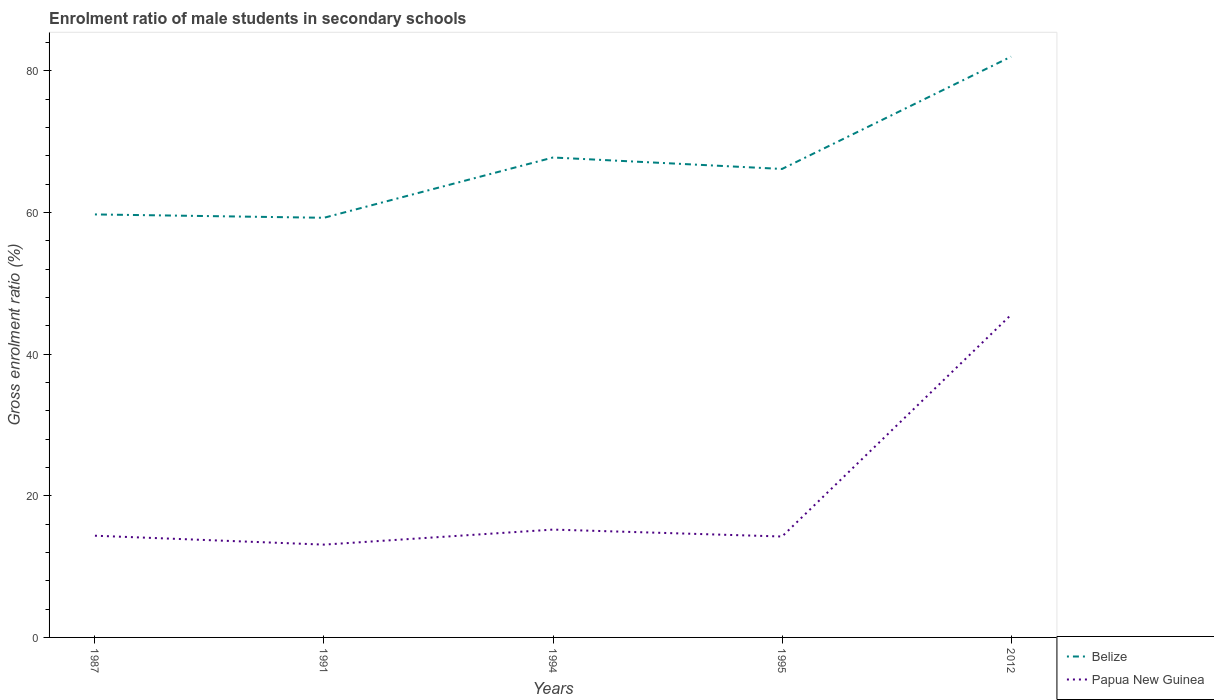Does the line corresponding to Papua New Guinea intersect with the line corresponding to Belize?
Your response must be concise. No. Is the number of lines equal to the number of legend labels?
Make the answer very short. Yes. Across all years, what is the maximum enrolment ratio of male students in secondary schools in Belize?
Give a very brief answer. 59.25. What is the total enrolment ratio of male students in secondary schools in Belize in the graph?
Offer a very short reply. -14.24. What is the difference between the highest and the second highest enrolment ratio of male students in secondary schools in Belize?
Make the answer very short. 22.75. Is the enrolment ratio of male students in secondary schools in Belize strictly greater than the enrolment ratio of male students in secondary schools in Papua New Guinea over the years?
Give a very brief answer. No. How many years are there in the graph?
Offer a terse response. 5. What is the difference between two consecutive major ticks on the Y-axis?
Offer a very short reply. 20. Are the values on the major ticks of Y-axis written in scientific E-notation?
Make the answer very short. No. What is the title of the graph?
Offer a terse response. Enrolment ratio of male students in secondary schools. Does "Jordan" appear as one of the legend labels in the graph?
Offer a terse response. No. What is the label or title of the X-axis?
Provide a succinct answer. Years. What is the Gross enrolment ratio (%) of Belize in 1987?
Make the answer very short. 59.72. What is the Gross enrolment ratio (%) of Papua New Guinea in 1987?
Your response must be concise. 14.36. What is the Gross enrolment ratio (%) of Belize in 1991?
Your answer should be compact. 59.25. What is the Gross enrolment ratio (%) in Papua New Guinea in 1991?
Offer a terse response. 13.1. What is the Gross enrolment ratio (%) in Belize in 1994?
Ensure brevity in your answer.  67.76. What is the Gross enrolment ratio (%) of Papua New Guinea in 1994?
Offer a terse response. 15.23. What is the Gross enrolment ratio (%) in Belize in 1995?
Your response must be concise. 66.14. What is the Gross enrolment ratio (%) of Papua New Guinea in 1995?
Keep it short and to the point. 14.25. What is the Gross enrolment ratio (%) in Belize in 2012?
Your response must be concise. 81.99. What is the Gross enrolment ratio (%) in Papua New Guinea in 2012?
Give a very brief answer. 45.56. Across all years, what is the maximum Gross enrolment ratio (%) in Belize?
Your answer should be very brief. 81.99. Across all years, what is the maximum Gross enrolment ratio (%) in Papua New Guinea?
Your answer should be very brief. 45.56. Across all years, what is the minimum Gross enrolment ratio (%) of Belize?
Your answer should be very brief. 59.25. Across all years, what is the minimum Gross enrolment ratio (%) of Papua New Guinea?
Give a very brief answer. 13.1. What is the total Gross enrolment ratio (%) in Belize in the graph?
Provide a short and direct response. 334.85. What is the total Gross enrolment ratio (%) in Papua New Guinea in the graph?
Provide a succinct answer. 102.49. What is the difference between the Gross enrolment ratio (%) of Belize in 1987 and that in 1991?
Keep it short and to the point. 0.47. What is the difference between the Gross enrolment ratio (%) in Papua New Guinea in 1987 and that in 1991?
Keep it short and to the point. 1.26. What is the difference between the Gross enrolment ratio (%) of Belize in 1987 and that in 1994?
Give a very brief answer. -8.04. What is the difference between the Gross enrolment ratio (%) in Papua New Guinea in 1987 and that in 1994?
Make the answer very short. -0.87. What is the difference between the Gross enrolment ratio (%) of Belize in 1987 and that in 1995?
Provide a succinct answer. -6.42. What is the difference between the Gross enrolment ratio (%) of Papua New Guinea in 1987 and that in 1995?
Give a very brief answer. 0.11. What is the difference between the Gross enrolment ratio (%) in Belize in 1987 and that in 2012?
Offer a terse response. -22.27. What is the difference between the Gross enrolment ratio (%) of Papua New Guinea in 1987 and that in 2012?
Your answer should be very brief. -31.2. What is the difference between the Gross enrolment ratio (%) in Belize in 1991 and that in 1994?
Your response must be concise. -8.51. What is the difference between the Gross enrolment ratio (%) in Papua New Guinea in 1991 and that in 1994?
Your answer should be compact. -2.12. What is the difference between the Gross enrolment ratio (%) in Belize in 1991 and that in 1995?
Provide a succinct answer. -6.89. What is the difference between the Gross enrolment ratio (%) of Papua New Guinea in 1991 and that in 1995?
Your response must be concise. -1.14. What is the difference between the Gross enrolment ratio (%) in Belize in 1991 and that in 2012?
Ensure brevity in your answer.  -22.75. What is the difference between the Gross enrolment ratio (%) in Papua New Guinea in 1991 and that in 2012?
Your answer should be very brief. -32.45. What is the difference between the Gross enrolment ratio (%) of Belize in 1994 and that in 1995?
Your answer should be compact. 1.62. What is the difference between the Gross enrolment ratio (%) in Papua New Guinea in 1994 and that in 1995?
Keep it short and to the point. 0.98. What is the difference between the Gross enrolment ratio (%) of Belize in 1994 and that in 2012?
Give a very brief answer. -14.24. What is the difference between the Gross enrolment ratio (%) of Papua New Guinea in 1994 and that in 2012?
Make the answer very short. -30.33. What is the difference between the Gross enrolment ratio (%) of Belize in 1995 and that in 2012?
Your answer should be very brief. -15.86. What is the difference between the Gross enrolment ratio (%) in Papua New Guinea in 1995 and that in 2012?
Ensure brevity in your answer.  -31.31. What is the difference between the Gross enrolment ratio (%) of Belize in 1987 and the Gross enrolment ratio (%) of Papua New Guinea in 1991?
Provide a short and direct response. 46.62. What is the difference between the Gross enrolment ratio (%) of Belize in 1987 and the Gross enrolment ratio (%) of Papua New Guinea in 1994?
Give a very brief answer. 44.49. What is the difference between the Gross enrolment ratio (%) of Belize in 1987 and the Gross enrolment ratio (%) of Papua New Guinea in 1995?
Ensure brevity in your answer.  45.47. What is the difference between the Gross enrolment ratio (%) of Belize in 1987 and the Gross enrolment ratio (%) of Papua New Guinea in 2012?
Your answer should be very brief. 14.16. What is the difference between the Gross enrolment ratio (%) in Belize in 1991 and the Gross enrolment ratio (%) in Papua New Guinea in 1994?
Provide a succinct answer. 44.02. What is the difference between the Gross enrolment ratio (%) in Belize in 1991 and the Gross enrolment ratio (%) in Papua New Guinea in 1995?
Offer a very short reply. 45. What is the difference between the Gross enrolment ratio (%) in Belize in 1991 and the Gross enrolment ratio (%) in Papua New Guinea in 2012?
Offer a very short reply. 13.69. What is the difference between the Gross enrolment ratio (%) of Belize in 1994 and the Gross enrolment ratio (%) of Papua New Guinea in 1995?
Ensure brevity in your answer.  53.51. What is the difference between the Gross enrolment ratio (%) of Belize in 1994 and the Gross enrolment ratio (%) of Papua New Guinea in 2012?
Your answer should be very brief. 22.2. What is the difference between the Gross enrolment ratio (%) in Belize in 1995 and the Gross enrolment ratio (%) in Papua New Guinea in 2012?
Make the answer very short. 20.58. What is the average Gross enrolment ratio (%) in Belize per year?
Make the answer very short. 66.97. What is the average Gross enrolment ratio (%) of Papua New Guinea per year?
Provide a short and direct response. 20.5. In the year 1987, what is the difference between the Gross enrolment ratio (%) of Belize and Gross enrolment ratio (%) of Papua New Guinea?
Offer a terse response. 45.36. In the year 1991, what is the difference between the Gross enrolment ratio (%) in Belize and Gross enrolment ratio (%) in Papua New Guinea?
Provide a short and direct response. 46.14. In the year 1994, what is the difference between the Gross enrolment ratio (%) in Belize and Gross enrolment ratio (%) in Papua New Guinea?
Make the answer very short. 52.53. In the year 1995, what is the difference between the Gross enrolment ratio (%) in Belize and Gross enrolment ratio (%) in Papua New Guinea?
Offer a terse response. 51.89. In the year 2012, what is the difference between the Gross enrolment ratio (%) of Belize and Gross enrolment ratio (%) of Papua New Guinea?
Give a very brief answer. 36.44. What is the ratio of the Gross enrolment ratio (%) of Belize in 1987 to that in 1991?
Offer a terse response. 1.01. What is the ratio of the Gross enrolment ratio (%) in Papua New Guinea in 1987 to that in 1991?
Provide a succinct answer. 1.1. What is the ratio of the Gross enrolment ratio (%) of Belize in 1987 to that in 1994?
Provide a succinct answer. 0.88. What is the ratio of the Gross enrolment ratio (%) of Papua New Guinea in 1987 to that in 1994?
Provide a succinct answer. 0.94. What is the ratio of the Gross enrolment ratio (%) in Belize in 1987 to that in 1995?
Offer a terse response. 0.9. What is the ratio of the Gross enrolment ratio (%) of Belize in 1987 to that in 2012?
Provide a short and direct response. 0.73. What is the ratio of the Gross enrolment ratio (%) in Papua New Guinea in 1987 to that in 2012?
Provide a short and direct response. 0.32. What is the ratio of the Gross enrolment ratio (%) of Belize in 1991 to that in 1994?
Provide a succinct answer. 0.87. What is the ratio of the Gross enrolment ratio (%) in Papua New Guinea in 1991 to that in 1994?
Provide a short and direct response. 0.86. What is the ratio of the Gross enrolment ratio (%) in Belize in 1991 to that in 1995?
Ensure brevity in your answer.  0.9. What is the ratio of the Gross enrolment ratio (%) in Papua New Guinea in 1991 to that in 1995?
Ensure brevity in your answer.  0.92. What is the ratio of the Gross enrolment ratio (%) of Belize in 1991 to that in 2012?
Provide a short and direct response. 0.72. What is the ratio of the Gross enrolment ratio (%) in Papua New Guinea in 1991 to that in 2012?
Offer a terse response. 0.29. What is the ratio of the Gross enrolment ratio (%) in Belize in 1994 to that in 1995?
Provide a short and direct response. 1.02. What is the ratio of the Gross enrolment ratio (%) in Papua New Guinea in 1994 to that in 1995?
Your answer should be compact. 1.07. What is the ratio of the Gross enrolment ratio (%) in Belize in 1994 to that in 2012?
Keep it short and to the point. 0.83. What is the ratio of the Gross enrolment ratio (%) in Papua New Guinea in 1994 to that in 2012?
Give a very brief answer. 0.33. What is the ratio of the Gross enrolment ratio (%) of Belize in 1995 to that in 2012?
Ensure brevity in your answer.  0.81. What is the ratio of the Gross enrolment ratio (%) of Papua New Guinea in 1995 to that in 2012?
Offer a terse response. 0.31. What is the difference between the highest and the second highest Gross enrolment ratio (%) in Belize?
Your answer should be very brief. 14.24. What is the difference between the highest and the second highest Gross enrolment ratio (%) in Papua New Guinea?
Your answer should be compact. 30.33. What is the difference between the highest and the lowest Gross enrolment ratio (%) of Belize?
Your answer should be very brief. 22.75. What is the difference between the highest and the lowest Gross enrolment ratio (%) in Papua New Guinea?
Provide a succinct answer. 32.45. 